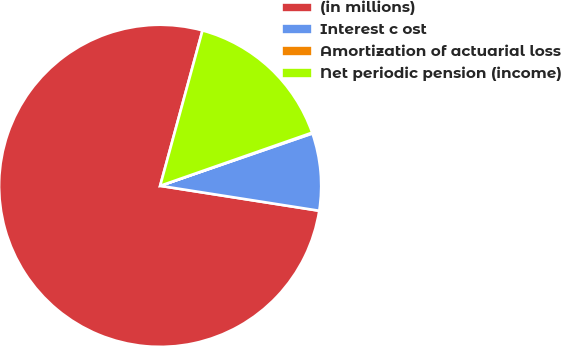Convert chart. <chart><loc_0><loc_0><loc_500><loc_500><pie_chart><fcel>(in millions)<fcel>Interest c ost<fcel>Amortization of actuarial loss<fcel>Net periodic pension (income)<nl><fcel>76.76%<fcel>7.75%<fcel>0.08%<fcel>15.41%<nl></chart> 